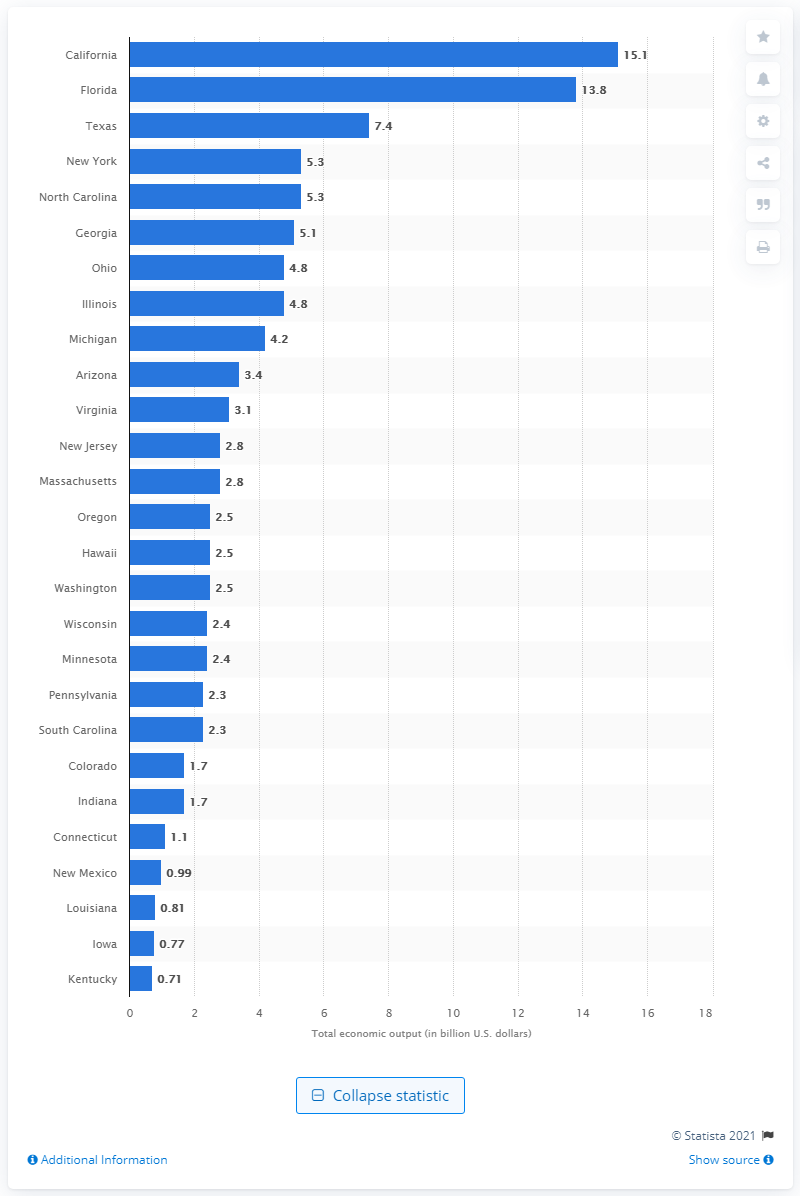List a handful of essential elements in this visual. The total economic output of the golf industry in New Mexico in 2006 was approximately $990,000. 